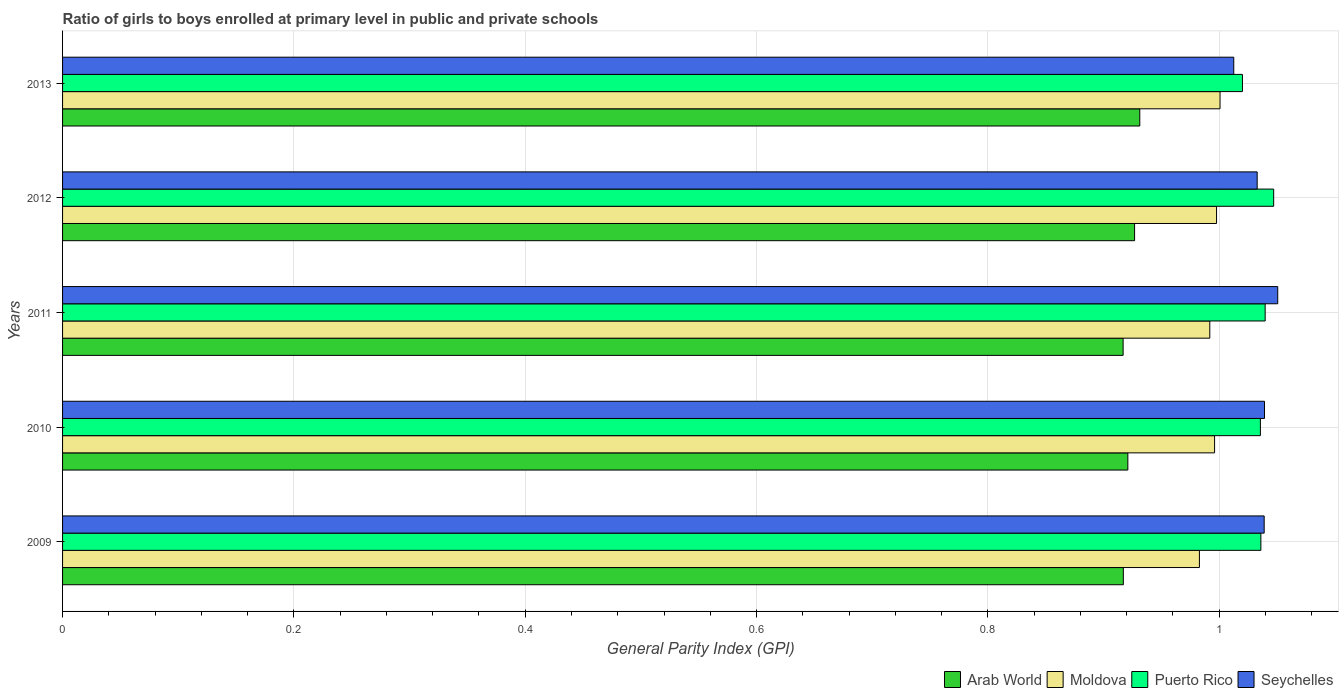How many different coloured bars are there?
Your answer should be compact. 4. How many groups of bars are there?
Provide a succinct answer. 5. Are the number of bars per tick equal to the number of legend labels?
Ensure brevity in your answer.  Yes. Are the number of bars on each tick of the Y-axis equal?
Your answer should be very brief. Yes. How many bars are there on the 2nd tick from the top?
Ensure brevity in your answer.  4. In how many cases, is the number of bars for a given year not equal to the number of legend labels?
Offer a very short reply. 0. What is the general parity index in Arab World in 2010?
Make the answer very short. 0.92. Across all years, what is the maximum general parity index in Seychelles?
Your answer should be very brief. 1.05. Across all years, what is the minimum general parity index in Puerto Rico?
Offer a very short reply. 1.02. In which year was the general parity index in Seychelles minimum?
Give a very brief answer. 2013. What is the total general parity index in Seychelles in the graph?
Give a very brief answer. 5.17. What is the difference between the general parity index in Puerto Rico in 2009 and that in 2011?
Offer a terse response. -0. What is the difference between the general parity index in Moldova in 2010 and the general parity index in Seychelles in 2012?
Ensure brevity in your answer.  -0.04. What is the average general parity index in Arab World per year?
Your answer should be compact. 0.92. In the year 2011, what is the difference between the general parity index in Seychelles and general parity index in Arab World?
Keep it short and to the point. 0.13. What is the ratio of the general parity index in Puerto Rico in 2009 to that in 2011?
Offer a very short reply. 1. Is the general parity index in Moldova in 2009 less than that in 2011?
Offer a very short reply. Yes. What is the difference between the highest and the second highest general parity index in Seychelles?
Keep it short and to the point. 0.01. What is the difference between the highest and the lowest general parity index in Puerto Rico?
Make the answer very short. 0.03. Is it the case that in every year, the sum of the general parity index in Puerto Rico and general parity index in Seychelles is greater than the sum of general parity index in Arab World and general parity index in Moldova?
Keep it short and to the point. Yes. What does the 2nd bar from the top in 2011 represents?
Your answer should be compact. Puerto Rico. What does the 1st bar from the bottom in 2011 represents?
Provide a succinct answer. Arab World. Are all the bars in the graph horizontal?
Ensure brevity in your answer.  Yes. How many years are there in the graph?
Ensure brevity in your answer.  5. What is the difference between two consecutive major ticks on the X-axis?
Ensure brevity in your answer.  0.2. Are the values on the major ticks of X-axis written in scientific E-notation?
Provide a short and direct response. No. What is the title of the graph?
Make the answer very short. Ratio of girls to boys enrolled at primary level in public and private schools. Does "Kyrgyz Republic" appear as one of the legend labels in the graph?
Offer a very short reply. No. What is the label or title of the X-axis?
Your response must be concise. General Parity Index (GPI). What is the General Parity Index (GPI) in Arab World in 2009?
Provide a short and direct response. 0.92. What is the General Parity Index (GPI) in Moldova in 2009?
Offer a terse response. 0.98. What is the General Parity Index (GPI) of Puerto Rico in 2009?
Your answer should be compact. 1.04. What is the General Parity Index (GPI) in Seychelles in 2009?
Keep it short and to the point. 1.04. What is the General Parity Index (GPI) of Arab World in 2010?
Give a very brief answer. 0.92. What is the General Parity Index (GPI) of Moldova in 2010?
Ensure brevity in your answer.  1. What is the General Parity Index (GPI) of Puerto Rico in 2010?
Provide a short and direct response. 1.04. What is the General Parity Index (GPI) in Seychelles in 2010?
Your answer should be compact. 1.04. What is the General Parity Index (GPI) in Arab World in 2011?
Your answer should be very brief. 0.92. What is the General Parity Index (GPI) in Moldova in 2011?
Keep it short and to the point. 0.99. What is the General Parity Index (GPI) in Puerto Rico in 2011?
Your response must be concise. 1.04. What is the General Parity Index (GPI) in Seychelles in 2011?
Give a very brief answer. 1.05. What is the General Parity Index (GPI) in Arab World in 2012?
Ensure brevity in your answer.  0.93. What is the General Parity Index (GPI) of Moldova in 2012?
Keep it short and to the point. 1. What is the General Parity Index (GPI) in Puerto Rico in 2012?
Provide a succinct answer. 1.05. What is the General Parity Index (GPI) of Seychelles in 2012?
Provide a succinct answer. 1.03. What is the General Parity Index (GPI) in Arab World in 2013?
Your answer should be compact. 0.93. What is the General Parity Index (GPI) in Moldova in 2013?
Offer a very short reply. 1. What is the General Parity Index (GPI) of Puerto Rico in 2013?
Make the answer very short. 1.02. What is the General Parity Index (GPI) of Seychelles in 2013?
Provide a succinct answer. 1.01. Across all years, what is the maximum General Parity Index (GPI) of Arab World?
Ensure brevity in your answer.  0.93. Across all years, what is the maximum General Parity Index (GPI) in Moldova?
Your answer should be compact. 1. Across all years, what is the maximum General Parity Index (GPI) of Puerto Rico?
Provide a succinct answer. 1.05. Across all years, what is the maximum General Parity Index (GPI) of Seychelles?
Your answer should be very brief. 1.05. Across all years, what is the minimum General Parity Index (GPI) in Arab World?
Give a very brief answer. 0.92. Across all years, what is the minimum General Parity Index (GPI) in Moldova?
Your answer should be very brief. 0.98. Across all years, what is the minimum General Parity Index (GPI) of Puerto Rico?
Your answer should be compact. 1.02. Across all years, what is the minimum General Parity Index (GPI) in Seychelles?
Provide a short and direct response. 1.01. What is the total General Parity Index (GPI) in Arab World in the graph?
Make the answer very short. 4.61. What is the total General Parity Index (GPI) in Moldova in the graph?
Provide a succinct answer. 4.97. What is the total General Parity Index (GPI) in Puerto Rico in the graph?
Make the answer very short. 5.18. What is the total General Parity Index (GPI) of Seychelles in the graph?
Your answer should be very brief. 5.17. What is the difference between the General Parity Index (GPI) in Arab World in 2009 and that in 2010?
Keep it short and to the point. -0. What is the difference between the General Parity Index (GPI) of Moldova in 2009 and that in 2010?
Make the answer very short. -0.01. What is the difference between the General Parity Index (GPI) in Puerto Rico in 2009 and that in 2010?
Offer a terse response. 0. What is the difference between the General Parity Index (GPI) in Seychelles in 2009 and that in 2010?
Make the answer very short. -0. What is the difference between the General Parity Index (GPI) of Moldova in 2009 and that in 2011?
Keep it short and to the point. -0.01. What is the difference between the General Parity Index (GPI) in Puerto Rico in 2009 and that in 2011?
Your answer should be very brief. -0. What is the difference between the General Parity Index (GPI) of Seychelles in 2009 and that in 2011?
Give a very brief answer. -0.01. What is the difference between the General Parity Index (GPI) of Arab World in 2009 and that in 2012?
Ensure brevity in your answer.  -0.01. What is the difference between the General Parity Index (GPI) in Moldova in 2009 and that in 2012?
Your response must be concise. -0.01. What is the difference between the General Parity Index (GPI) of Puerto Rico in 2009 and that in 2012?
Provide a succinct answer. -0.01. What is the difference between the General Parity Index (GPI) of Seychelles in 2009 and that in 2012?
Offer a terse response. 0.01. What is the difference between the General Parity Index (GPI) in Arab World in 2009 and that in 2013?
Give a very brief answer. -0.01. What is the difference between the General Parity Index (GPI) of Moldova in 2009 and that in 2013?
Offer a terse response. -0.02. What is the difference between the General Parity Index (GPI) of Puerto Rico in 2009 and that in 2013?
Your response must be concise. 0.02. What is the difference between the General Parity Index (GPI) of Seychelles in 2009 and that in 2013?
Provide a short and direct response. 0.03. What is the difference between the General Parity Index (GPI) of Arab World in 2010 and that in 2011?
Provide a succinct answer. 0. What is the difference between the General Parity Index (GPI) of Moldova in 2010 and that in 2011?
Offer a very short reply. 0. What is the difference between the General Parity Index (GPI) in Puerto Rico in 2010 and that in 2011?
Provide a short and direct response. -0. What is the difference between the General Parity Index (GPI) of Seychelles in 2010 and that in 2011?
Offer a terse response. -0.01. What is the difference between the General Parity Index (GPI) of Arab World in 2010 and that in 2012?
Offer a terse response. -0.01. What is the difference between the General Parity Index (GPI) of Moldova in 2010 and that in 2012?
Provide a succinct answer. -0. What is the difference between the General Parity Index (GPI) in Puerto Rico in 2010 and that in 2012?
Keep it short and to the point. -0.01. What is the difference between the General Parity Index (GPI) in Seychelles in 2010 and that in 2012?
Your response must be concise. 0.01. What is the difference between the General Parity Index (GPI) of Arab World in 2010 and that in 2013?
Make the answer very short. -0.01. What is the difference between the General Parity Index (GPI) in Moldova in 2010 and that in 2013?
Your answer should be very brief. -0. What is the difference between the General Parity Index (GPI) of Puerto Rico in 2010 and that in 2013?
Provide a succinct answer. 0.02. What is the difference between the General Parity Index (GPI) in Seychelles in 2010 and that in 2013?
Make the answer very short. 0.03. What is the difference between the General Parity Index (GPI) of Arab World in 2011 and that in 2012?
Offer a very short reply. -0.01. What is the difference between the General Parity Index (GPI) of Moldova in 2011 and that in 2012?
Your answer should be compact. -0.01. What is the difference between the General Parity Index (GPI) in Puerto Rico in 2011 and that in 2012?
Make the answer very short. -0.01. What is the difference between the General Parity Index (GPI) of Seychelles in 2011 and that in 2012?
Make the answer very short. 0.02. What is the difference between the General Parity Index (GPI) of Arab World in 2011 and that in 2013?
Give a very brief answer. -0.01. What is the difference between the General Parity Index (GPI) of Moldova in 2011 and that in 2013?
Your response must be concise. -0.01. What is the difference between the General Parity Index (GPI) in Puerto Rico in 2011 and that in 2013?
Your response must be concise. 0.02. What is the difference between the General Parity Index (GPI) in Seychelles in 2011 and that in 2013?
Your answer should be compact. 0.04. What is the difference between the General Parity Index (GPI) in Arab World in 2012 and that in 2013?
Offer a very short reply. -0. What is the difference between the General Parity Index (GPI) of Moldova in 2012 and that in 2013?
Offer a very short reply. -0. What is the difference between the General Parity Index (GPI) of Puerto Rico in 2012 and that in 2013?
Provide a short and direct response. 0.03. What is the difference between the General Parity Index (GPI) in Seychelles in 2012 and that in 2013?
Make the answer very short. 0.02. What is the difference between the General Parity Index (GPI) in Arab World in 2009 and the General Parity Index (GPI) in Moldova in 2010?
Keep it short and to the point. -0.08. What is the difference between the General Parity Index (GPI) of Arab World in 2009 and the General Parity Index (GPI) of Puerto Rico in 2010?
Ensure brevity in your answer.  -0.12. What is the difference between the General Parity Index (GPI) of Arab World in 2009 and the General Parity Index (GPI) of Seychelles in 2010?
Ensure brevity in your answer.  -0.12. What is the difference between the General Parity Index (GPI) of Moldova in 2009 and the General Parity Index (GPI) of Puerto Rico in 2010?
Offer a very short reply. -0.05. What is the difference between the General Parity Index (GPI) of Moldova in 2009 and the General Parity Index (GPI) of Seychelles in 2010?
Your answer should be compact. -0.06. What is the difference between the General Parity Index (GPI) in Puerto Rico in 2009 and the General Parity Index (GPI) in Seychelles in 2010?
Provide a succinct answer. -0. What is the difference between the General Parity Index (GPI) in Arab World in 2009 and the General Parity Index (GPI) in Moldova in 2011?
Keep it short and to the point. -0.07. What is the difference between the General Parity Index (GPI) of Arab World in 2009 and the General Parity Index (GPI) of Puerto Rico in 2011?
Make the answer very short. -0.12. What is the difference between the General Parity Index (GPI) of Arab World in 2009 and the General Parity Index (GPI) of Seychelles in 2011?
Your response must be concise. -0.13. What is the difference between the General Parity Index (GPI) of Moldova in 2009 and the General Parity Index (GPI) of Puerto Rico in 2011?
Provide a short and direct response. -0.06. What is the difference between the General Parity Index (GPI) of Moldova in 2009 and the General Parity Index (GPI) of Seychelles in 2011?
Your answer should be compact. -0.07. What is the difference between the General Parity Index (GPI) of Puerto Rico in 2009 and the General Parity Index (GPI) of Seychelles in 2011?
Ensure brevity in your answer.  -0.01. What is the difference between the General Parity Index (GPI) of Arab World in 2009 and the General Parity Index (GPI) of Moldova in 2012?
Your response must be concise. -0.08. What is the difference between the General Parity Index (GPI) of Arab World in 2009 and the General Parity Index (GPI) of Puerto Rico in 2012?
Your answer should be very brief. -0.13. What is the difference between the General Parity Index (GPI) in Arab World in 2009 and the General Parity Index (GPI) in Seychelles in 2012?
Provide a succinct answer. -0.12. What is the difference between the General Parity Index (GPI) in Moldova in 2009 and the General Parity Index (GPI) in Puerto Rico in 2012?
Your response must be concise. -0.06. What is the difference between the General Parity Index (GPI) in Moldova in 2009 and the General Parity Index (GPI) in Seychelles in 2012?
Make the answer very short. -0.05. What is the difference between the General Parity Index (GPI) in Puerto Rico in 2009 and the General Parity Index (GPI) in Seychelles in 2012?
Ensure brevity in your answer.  0. What is the difference between the General Parity Index (GPI) of Arab World in 2009 and the General Parity Index (GPI) of Moldova in 2013?
Your response must be concise. -0.08. What is the difference between the General Parity Index (GPI) of Arab World in 2009 and the General Parity Index (GPI) of Puerto Rico in 2013?
Provide a succinct answer. -0.1. What is the difference between the General Parity Index (GPI) of Arab World in 2009 and the General Parity Index (GPI) of Seychelles in 2013?
Give a very brief answer. -0.1. What is the difference between the General Parity Index (GPI) of Moldova in 2009 and the General Parity Index (GPI) of Puerto Rico in 2013?
Provide a short and direct response. -0.04. What is the difference between the General Parity Index (GPI) in Moldova in 2009 and the General Parity Index (GPI) in Seychelles in 2013?
Your answer should be very brief. -0.03. What is the difference between the General Parity Index (GPI) of Puerto Rico in 2009 and the General Parity Index (GPI) of Seychelles in 2013?
Give a very brief answer. 0.02. What is the difference between the General Parity Index (GPI) in Arab World in 2010 and the General Parity Index (GPI) in Moldova in 2011?
Make the answer very short. -0.07. What is the difference between the General Parity Index (GPI) in Arab World in 2010 and the General Parity Index (GPI) in Puerto Rico in 2011?
Provide a short and direct response. -0.12. What is the difference between the General Parity Index (GPI) of Arab World in 2010 and the General Parity Index (GPI) of Seychelles in 2011?
Give a very brief answer. -0.13. What is the difference between the General Parity Index (GPI) of Moldova in 2010 and the General Parity Index (GPI) of Puerto Rico in 2011?
Your response must be concise. -0.04. What is the difference between the General Parity Index (GPI) of Moldova in 2010 and the General Parity Index (GPI) of Seychelles in 2011?
Ensure brevity in your answer.  -0.05. What is the difference between the General Parity Index (GPI) in Puerto Rico in 2010 and the General Parity Index (GPI) in Seychelles in 2011?
Provide a succinct answer. -0.01. What is the difference between the General Parity Index (GPI) of Arab World in 2010 and the General Parity Index (GPI) of Moldova in 2012?
Keep it short and to the point. -0.08. What is the difference between the General Parity Index (GPI) of Arab World in 2010 and the General Parity Index (GPI) of Puerto Rico in 2012?
Your response must be concise. -0.13. What is the difference between the General Parity Index (GPI) in Arab World in 2010 and the General Parity Index (GPI) in Seychelles in 2012?
Make the answer very short. -0.11. What is the difference between the General Parity Index (GPI) in Moldova in 2010 and the General Parity Index (GPI) in Puerto Rico in 2012?
Provide a succinct answer. -0.05. What is the difference between the General Parity Index (GPI) in Moldova in 2010 and the General Parity Index (GPI) in Seychelles in 2012?
Provide a short and direct response. -0.04. What is the difference between the General Parity Index (GPI) in Puerto Rico in 2010 and the General Parity Index (GPI) in Seychelles in 2012?
Keep it short and to the point. 0. What is the difference between the General Parity Index (GPI) in Arab World in 2010 and the General Parity Index (GPI) in Moldova in 2013?
Make the answer very short. -0.08. What is the difference between the General Parity Index (GPI) in Arab World in 2010 and the General Parity Index (GPI) in Puerto Rico in 2013?
Provide a succinct answer. -0.1. What is the difference between the General Parity Index (GPI) in Arab World in 2010 and the General Parity Index (GPI) in Seychelles in 2013?
Your response must be concise. -0.09. What is the difference between the General Parity Index (GPI) in Moldova in 2010 and the General Parity Index (GPI) in Puerto Rico in 2013?
Your response must be concise. -0.02. What is the difference between the General Parity Index (GPI) in Moldova in 2010 and the General Parity Index (GPI) in Seychelles in 2013?
Offer a very short reply. -0.02. What is the difference between the General Parity Index (GPI) of Puerto Rico in 2010 and the General Parity Index (GPI) of Seychelles in 2013?
Your response must be concise. 0.02. What is the difference between the General Parity Index (GPI) in Arab World in 2011 and the General Parity Index (GPI) in Moldova in 2012?
Offer a terse response. -0.08. What is the difference between the General Parity Index (GPI) in Arab World in 2011 and the General Parity Index (GPI) in Puerto Rico in 2012?
Offer a very short reply. -0.13. What is the difference between the General Parity Index (GPI) of Arab World in 2011 and the General Parity Index (GPI) of Seychelles in 2012?
Provide a short and direct response. -0.12. What is the difference between the General Parity Index (GPI) in Moldova in 2011 and the General Parity Index (GPI) in Puerto Rico in 2012?
Your response must be concise. -0.06. What is the difference between the General Parity Index (GPI) of Moldova in 2011 and the General Parity Index (GPI) of Seychelles in 2012?
Provide a short and direct response. -0.04. What is the difference between the General Parity Index (GPI) of Puerto Rico in 2011 and the General Parity Index (GPI) of Seychelles in 2012?
Offer a very short reply. 0.01. What is the difference between the General Parity Index (GPI) in Arab World in 2011 and the General Parity Index (GPI) in Moldova in 2013?
Offer a terse response. -0.08. What is the difference between the General Parity Index (GPI) of Arab World in 2011 and the General Parity Index (GPI) of Puerto Rico in 2013?
Keep it short and to the point. -0.1. What is the difference between the General Parity Index (GPI) in Arab World in 2011 and the General Parity Index (GPI) in Seychelles in 2013?
Give a very brief answer. -0.1. What is the difference between the General Parity Index (GPI) in Moldova in 2011 and the General Parity Index (GPI) in Puerto Rico in 2013?
Offer a very short reply. -0.03. What is the difference between the General Parity Index (GPI) of Moldova in 2011 and the General Parity Index (GPI) of Seychelles in 2013?
Keep it short and to the point. -0.02. What is the difference between the General Parity Index (GPI) in Puerto Rico in 2011 and the General Parity Index (GPI) in Seychelles in 2013?
Make the answer very short. 0.03. What is the difference between the General Parity Index (GPI) in Arab World in 2012 and the General Parity Index (GPI) in Moldova in 2013?
Make the answer very short. -0.07. What is the difference between the General Parity Index (GPI) of Arab World in 2012 and the General Parity Index (GPI) of Puerto Rico in 2013?
Keep it short and to the point. -0.09. What is the difference between the General Parity Index (GPI) in Arab World in 2012 and the General Parity Index (GPI) in Seychelles in 2013?
Provide a short and direct response. -0.09. What is the difference between the General Parity Index (GPI) in Moldova in 2012 and the General Parity Index (GPI) in Puerto Rico in 2013?
Provide a short and direct response. -0.02. What is the difference between the General Parity Index (GPI) in Moldova in 2012 and the General Parity Index (GPI) in Seychelles in 2013?
Offer a terse response. -0.01. What is the difference between the General Parity Index (GPI) of Puerto Rico in 2012 and the General Parity Index (GPI) of Seychelles in 2013?
Offer a very short reply. 0.03. What is the average General Parity Index (GPI) of Arab World per year?
Your answer should be compact. 0.92. What is the average General Parity Index (GPI) of Puerto Rico per year?
Offer a very short reply. 1.04. What is the average General Parity Index (GPI) of Seychelles per year?
Your answer should be very brief. 1.03. In the year 2009, what is the difference between the General Parity Index (GPI) in Arab World and General Parity Index (GPI) in Moldova?
Provide a short and direct response. -0.07. In the year 2009, what is the difference between the General Parity Index (GPI) in Arab World and General Parity Index (GPI) in Puerto Rico?
Provide a short and direct response. -0.12. In the year 2009, what is the difference between the General Parity Index (GPI) of Arab World and General Parity Index (GPI) of Seychelles?
Provide a succinct answer. -0.12. In the year 2009, what is the difference between the General Parity Index (GPI) in Moldova and General Parity Index (GPI) in Puerto Rico?
Keep it short and to the point. -0.05. In the year 2009, what is the difference between the General Parity Index (GPI) of Moldova and General Parity Index (GPI) of Seychelles?
Make the answer very short. -0.06. In the year 2009, what is the difference between the General Parity Index (GPI) of Puerto Rico and General Parity Index (GPI) of Seychelles?
Keep it short and to the point. -0. In the year 2010, what is the difference between the General Parity Index (GPI) of Arab World and General Parity Index (GPI) of Moldova?
Make the answer very short. -0.07. In the year 2010, what is the difference between the General Parity Index (GPI) in Arab World and General Parity Index (GPI) in Puerto Rico?
Your answer should be very brief. -0.11. In the year 2010, what is the difference between the General Parity Index (GPI) in Arab World and General Parity Index (GPI) in Seychelles?
Offer a terse response. -0.12. In the year 2010, what is the difference between the General Parity Index (GPI) of Moldova and General Parity Index (GPI) of Puerto Rico?
Your answer should be very brief. -0.04. In the year 2010, what is the difference between the General Parity Index (GPI) in Moldova and General Parity Index (GPI) in Seychelles?
Your answer should be compact. -0.04. In the year 2010, what is the difference between the General Parity Index (GPI) in Puerto Rico and General Parity Index (GPI) in Seychelles?
Provide a short and direct response. -0. In the year 2011, what is the difference between the General Parity Index (GPI) of Arab World and General Parity Index (GPI) of Moldova?
Provide a succinct answer. -0.07. In the year 2011, what is the difference between the General Parity Index (GPI) of Arab World and General Parity Index (GPI) of Puerto Rico?
Ensure brevity in your answer.  -0.12. In the year 2011, what is the difference between the General Parity Index (GPI) in Arab World and General Parity Index (GPI) in Seychelles?
Keep it short and to the point. -0.13. In the year 2011, what is the difference between the General Parity Index (GPI) in Moldova and General Parity Index (GPI) in Puerto Rico?
Provide a succinct answer. -0.05. In the year 2011, what is the difference between the General Parity Index (GPI) in Moldova and General Parity Index (GPI) in Seychelles?
Provide a short and direct response. -0.06. In the year 2011, what is the difference between the General Parity Index (GPI) of Puerto Rico and General Parity Index (GPI) of Seychelles?
Make the answer very short. -0.01. In the year 2012, what is the difference between the General Parity Index (GPI) of Arab World and General Parity Index (GPI) of Moldova?
Ensure brevity in your answer.  -0.07. In the year 2012, what is the difference between the General Parity Index (GPI) in Arab World and General Parity Index (GPI) in Puerto Rico?
Offer a terse response. -0.12. In the year 2012, what is the difference between the General Parity Index (GPI) of Arab World and General Parity Index (GPI) of Seychelles?
Ensure brevity in your answer.  -0.11. In the year 2012, what is the difference between the General Parity Index (GPI) in Moldova and General Parity Index (GPI) in Puerto Rico?
Your answer should be compact. -0.05. In the year 2012, what is the difference between the General Parity Index (GPI) of Moldova and General Parity Index (GPI) of Seychelles?
Give a very brief answer. -0.04. In the year 2012, what is the difference between the General Parity Index (GPI) of Puerto Rico and General Parity Index (GPI) of Seychelles?
Offer a very short reply. 0.01. In the year 2013, what is the difference between the General Parity Index (GPI) of Arab World and General Parity Index (GPI) of Moldova?
Make the answer very short. -0.07. In the year 2013, what is the difference between the General Parity Index (GPI) of Arab World and General Parity Index (GPI) of Puerto Rico?
Provide a short and direct response. -0.09. In the year 2013, what is the difference between the General Parity Index (GPI) in Arab World and General Parity Index (GPI) in Seychelles?
Offer a very short reply. -0.08. In the year 2013, what is the difference between the General Parity Index (GPI) in Moldova and General Parity Index (GPI) in Puerto Rico?
Provide a succinct answer. -0.02. In the year 2013, what is the difference between the General Parity Index (GPI) in Moldova and General Parity Index (GPI) in Seychelles?
Make the answer very short. -0.01. In the year 2013, what is the difference between the General Parity Index (GPI) in Puerto Rico and General Parity Index (GPI) in Seychelles?
Your answer should be compact. 0.01. What is the ratio of the General Parity Index (GPI) in Arab World in 2009 to that in 2010?
Ensure brevity in your answer.  1. What is the ratio of the General Parity Index (GPI) in Puerto Rico in 2009 to that in 2010?
Your answer should be very brief. 1. What is the ratio of the General Parity Index (GPI) in Moldova in 2009 to that in 2011?
Your response must be concise. 0.99. What is the ratio of the General Parity Index (GPI) in Arab World in 2009 to that in 2012?
Provide a succinct answer. 0.99. What is the ratio of the General Parity Index (GPI) of Moldova in 2009 to that in 2012?
Provide a short and direct response. 0.99. What is the ratio of the General Parity Index (GPI) in Puerto Rico in 2009 to that in 2012?
Provide a succinct answer. 0.99. What is the ratio of the General Parity Index (GPI) in Seychelles in 2009 to that in 2012?
Your answer should be compact. 1.01. What is the ratio of the General Parity Index (GPI) in Arab World in 2009 to that in 2013?
Ensure brevity in your answer.  0.98. What is the ratio of the General Parity Index (GPI) in Moldova in 2009 to that in 2013?
Provide a succinct answer. 0.98. What is the ratio of the General Parity Index (GPI) of Puerto Rico in 2009 to that in 2013?
Your answer should be very brief. 1.02. What is the ratio of the General Parity Index (GPI) in Moldova in 2010 to that in 2011?
Keep it short and to the point. 1. What is the ratio of the General Parity Index (GPI) of Puerto Rico in 2010 to that in 2012?
Give a very brief answer. 0.99. What is the ratio of the General Parity Index (GPI) of Seychelles in 2010 to that in 2012?
Keep it short and to the point. 1.01. What is the ratio of the General Parity Index (GPI) of Arab World in 2010 to that in 2013?
Ensure brevity in your answer.  0.99. What is the ratio of the General Parity Index (GPI) in Moldova in 2010 to that in 2013?
Provide a succinct answer. 1. What is the ratio of the General Parity Index (GPI) in Puerto Rico in 2010 to that in 2013?
Provide a succinct answer. 1.02. What is the ratio of the General Parity Index (GPI) of Seychelles in 2010 to that in 2013?
Offer a terse response. 1.03. What is the ratio of the General Parity Index (GPI) in Arab World in 2011 to that in 2012?
Offer a terse response. 0.99. What is the ratio of the General Parity Index (GPI) of Puerto Rico in 2011 to that in 2012?
Make the answer very short. 0.99. What is the ratio of the General Parity Index (GPI) of Seychelles in 2011 to that in 2012?
Keep it short and to the point. 1.02. What is the ratio of the General Parity Index (GPI) of Arab World in 2011 to that in 2013?
Make the answer very short. 0.98. What is the ratio of the General Parity Index (GPI) of Moldova in 2011 to that in 2013?
Offer a very short reply. 0.99. What is the ratio of the General Parity Index (GPI) in Puerto Rico in 2011 to that in 2013?
Offer a very short reply. 1.02. What is the ratio of the General Parity Index (GPI) of Seychelles in 2011 to that in 2013?
Your response must be concise. 1.04. What is the ratio of the General Parity Index (GPI) in Moldova in 2012 to that in 2013?
Offer a very short reply. 1. What is the ratio of the General Parity Index (GPI) in Puerto Rico in 2012 to that in 2013?
Make the answer very short. 1.03. What is the difference between the highest and the second highest General Parity Index (GPI) of Arab World?
Your response must be concise. 0. What is the difference between the highest and the second highest General Parity Index (GPI) in Moldova?
Ensure brevity in your answer.  0. What is the difference between the highest and the second highest General Parity Index (GPI) in Puerto Rico?
Ensure brevity in your answer.  0.01. What is the difference between the highest and the second highest General Parity Index (GPI) in Seychelles?
Your answer should be compact. 0.01. What is the difference between the highest and the lowest General Parity Index (GPI) of Arab World?
Keep it short and to the point. 0.01. What is the difference between the highest and the lowest General Parity Index (GPI) of Moldova?
Provide a succinct answer. 0.02. What is the difference between the highest and the lowest General Parity Index (GPI) of Puerto Rico?
Offer a terse response. 0.03. What is the difference between the highest and the lowest General Parity Index (GPI) of Seychelles?
Offer a terse response. 0.04. 